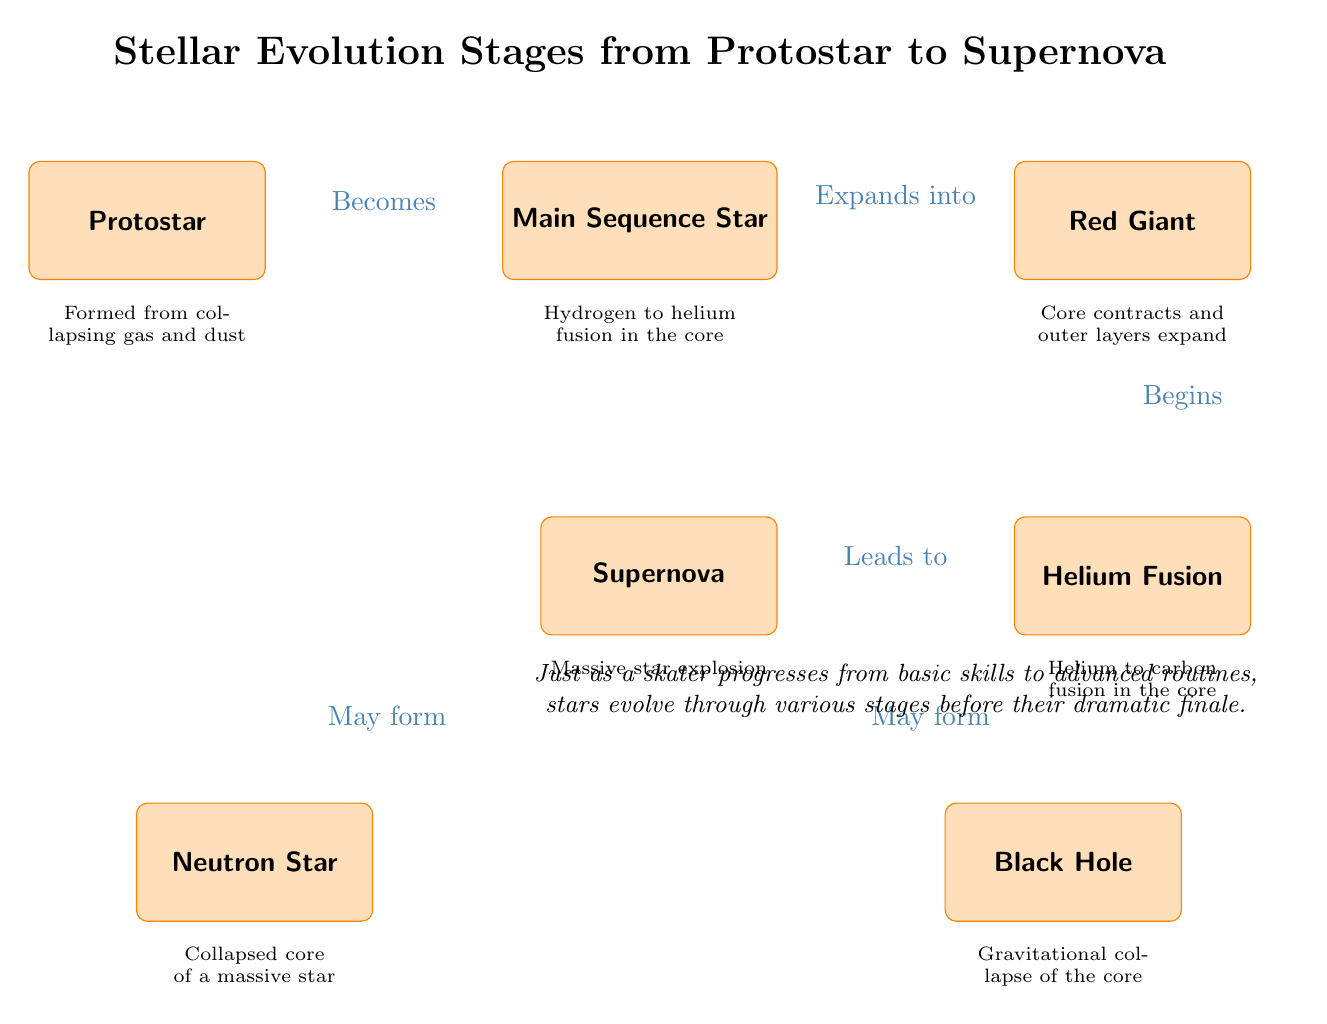What is the first stage of stellar evolution? The diagram shows the first node as "Protostar," which is the initial phase of a star's life cycle formed from collapsing gas and dust.
Answer: Protostar How many stages are shown in the diagram? There are six nodes labeled in the diagram representing different stages of stellar evolution: Protostar, Main Sequence Star, Red Giant, Helium Fusion, Supernova, Neutron Star, and Black Hole.
Answer: Six What stage does the Main Sequence Star evolve into? The arrow in the diagram indicates that the Main Sequence Star evolves into a Red Giant as it expands.
Answer: Red Giant Which two types of remnants may result from a Supernova? The diagram displays two nodes beneath Supernova labeled "Neutron Star" and "Black Hole," indicating that these are potential remnants formed after the explosion.
Answer: Neutron Star and Black Hole What process begins when a Red Giant reaches a certain point? The diagram indicates that after reaching the Red Giant stage, the star begins Helium Fusion as shown by the arrow leading to the Helium Fusion node.
Answer: Helium Fusion What happens during the Supernova stage? The label connected to the Supernova node states "Massive star explosion," which is an explosive event marking the end of a star's life cycle in this stage.
Answer: Massive star explosion Which stage transitions from Helium Fusion directly to Supernova? The Helium Fusion stage connects to the Supernova stage directly, meaning that the process of Helium Fusion eventually leads to a Supernova.
Answer: Supernova What type of events characterize the transition from Protostar to Main Sequence Star? The transition is characterized by the formation of the Protostar from collapsing gas and dust, leading to hydrogen fusion processes in the core, as shown in the diagram.
Answer: Hydrogen fusion How does the Red Giant phase describe the changes occurring? The diagram notes that during the Red Giant stage, the core contracts while the outer layers expand, indicating a significant transformation in the star's structure.
Answer: Core contracts and outer layers expand 